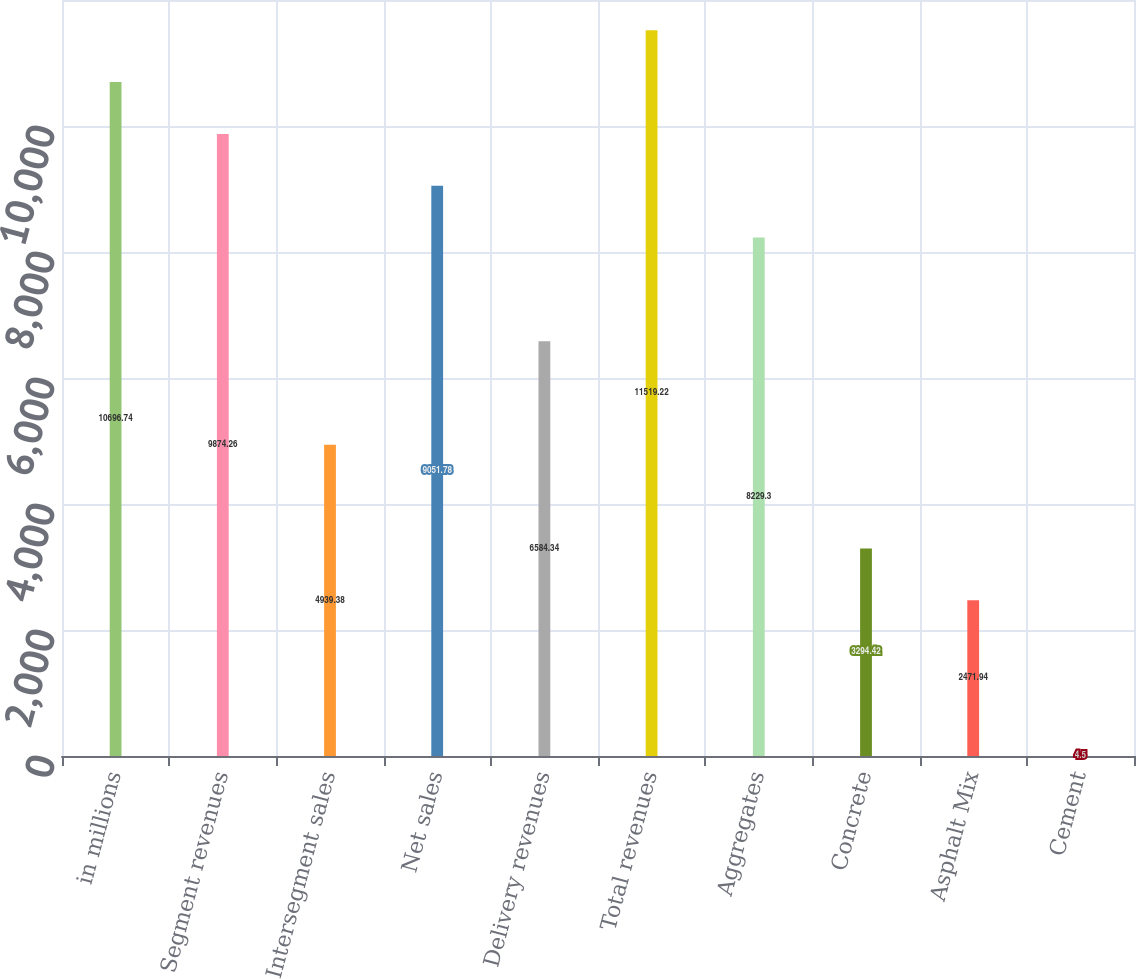Convert chart to OTSL. <chart><loc_0><loc_0><loc_500><loc_500><bar_chart><fcel>in millions<fcel>Segment revenues<fcel>Intersegment sales<fcel>Net sales<fcel>Delivery revenues<fcel>Total revenues<fcel>Aggregates<fcel>Concrete<fcel>Asphalt Mix<fcel>Cement<nl><fcel>10696.7<fcel>9874.26<fcel>4939.38<fcel>9051.78<fcel>6584.34<fcel>11519.2<fcel>8229.3<fcel>3294.42<fcel>2471.94<fcel>4.5<nl></chart> 